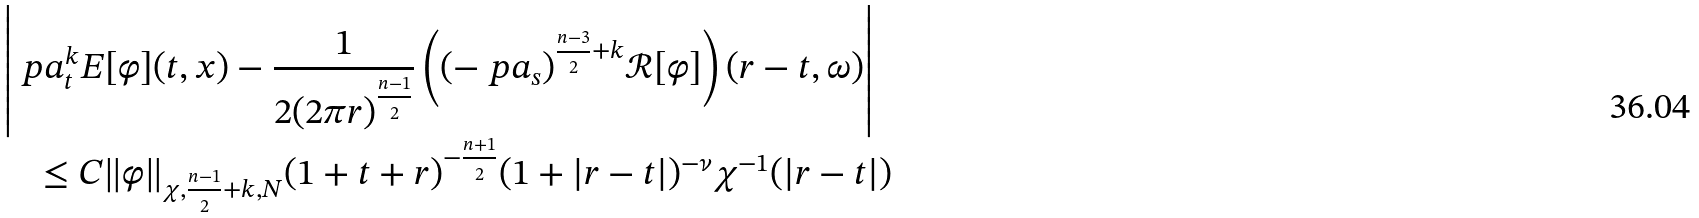<formula> <loc_0><loc_0><loc_500><loc_500>& \left | \ p a _ { t } ^ { k } E [ \varphi ] ( t , x ) - \frac { 1 } { 2 ( 2 \pi r ) ^ { \frac { n - 1 } 2 } } \left ( ( - \ p a _ { s } ) ^ { \frac { n - 3 } 2 + k } { \mathcal { R } } [ \varphi ] \right ) ( r - t , \omega ) \right | \\ & \quad \leq C \| \varphi \| _ { \chi , \frac { n - 1 } 2 + k , N } ( 1 + t + r ) ^ { - \frac { n + 1 } 2 } ( 1 + | r - t | ) ^ { - \nu } \chi ^ { - 1 } ( | r - t | )</formula> 